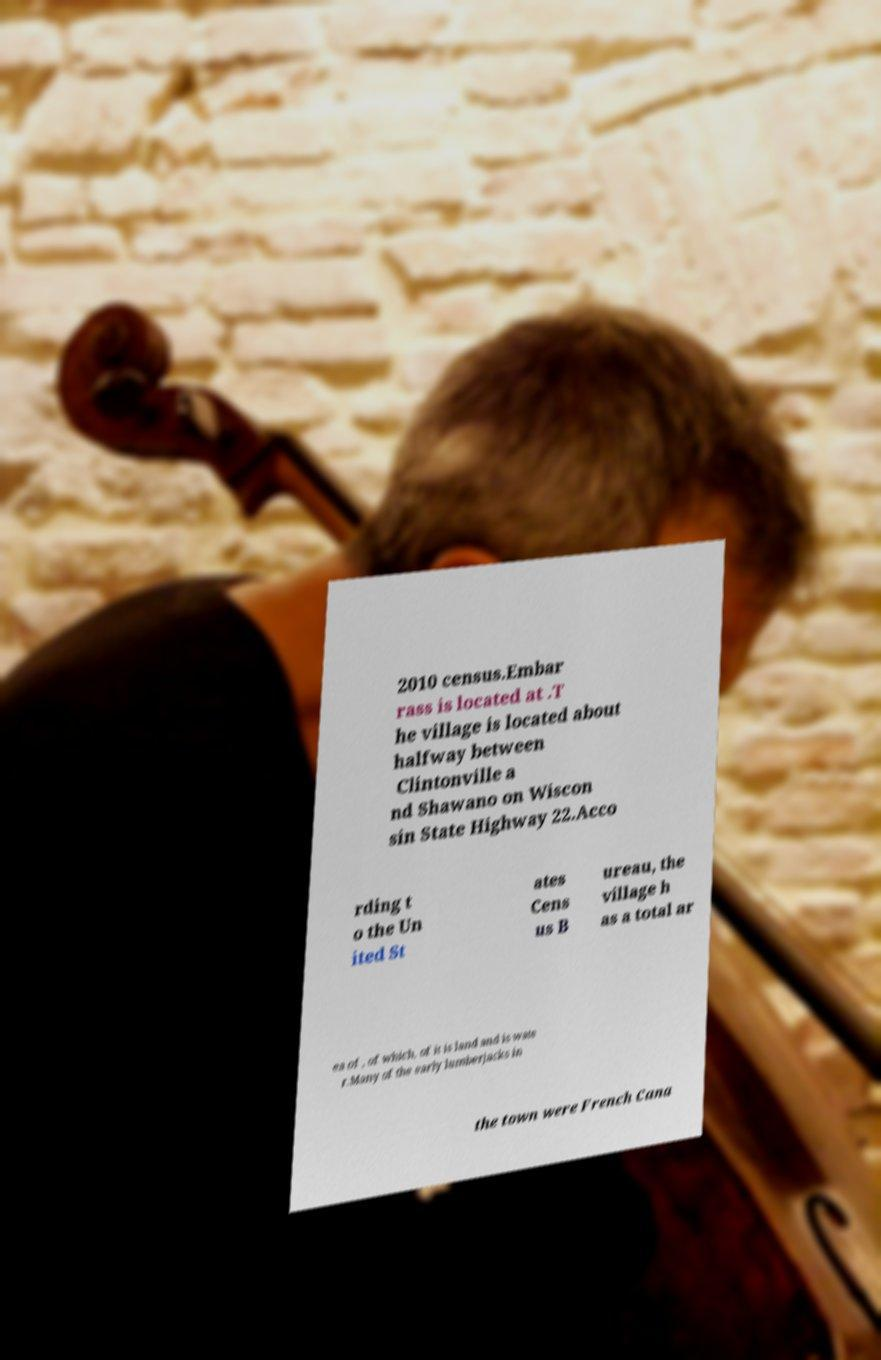I need the written content from this picture converted into text. Can you do that? 2010 census.Embar rass is located at .T he village is located about halfway between Clintonville a nd Shawano on Wiscon sin State Highway 22.Acco rding t o the Un ited St ates Cens us B ureau, the village h as a total ar ea of , of which, of it is land and is wate r.Many of the early lumberjacks in the town were French Cana 